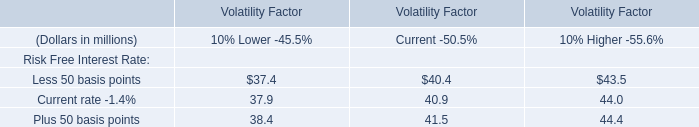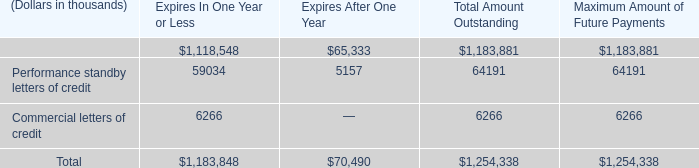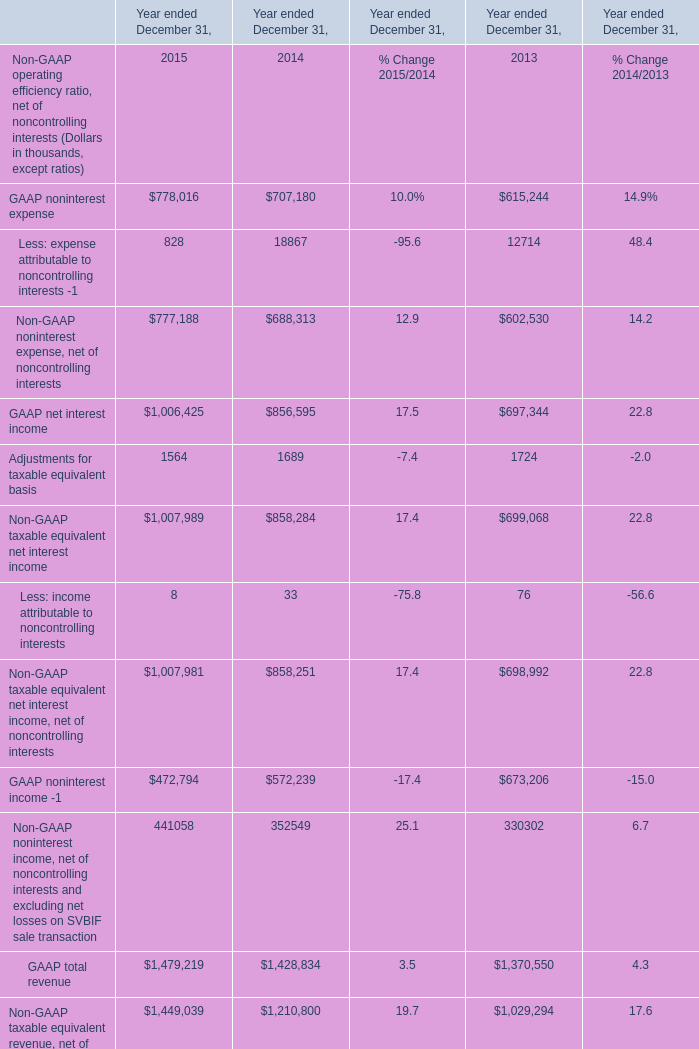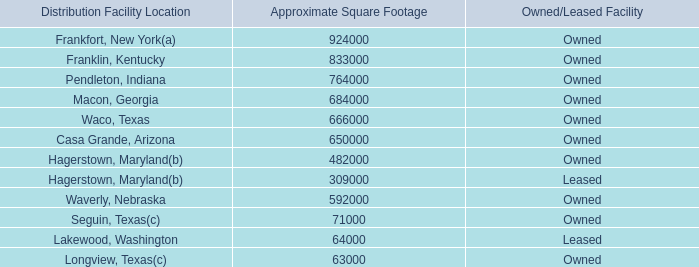what is the total texas facilities square footage? 
Computations: ((71000 + 63000) + 666000)
Answer: 800000.0. 